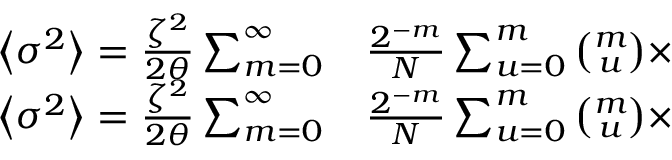Convert formula to latex. <formula><loc_0><loc_0><loc_500><loc_500>\begin{array} { r l } { \left \langle \sigma ^ { 2 } \right \rangle = \frac { \zeta ^ { 2 } } { 2 \theta } \sum _ { m = 0 } ^ { \infty } } & \frac { 2 ^ { - m } } { N } \sum _ { u = 0 } ^ { m } \binom { m } { u } \times } \\ { \left \langle \sigma ^ { 2 } \right \rangle = \frac { \zeta ^ { 2 } } { 2 \theta } \sum _ { m = 0 } ^ { \infty } } & \frac { 2 ^ { - m } } { N } \sum _ { u = 0 } ^ { m } \binom { m } { u } \times } \end{array}</formula> 